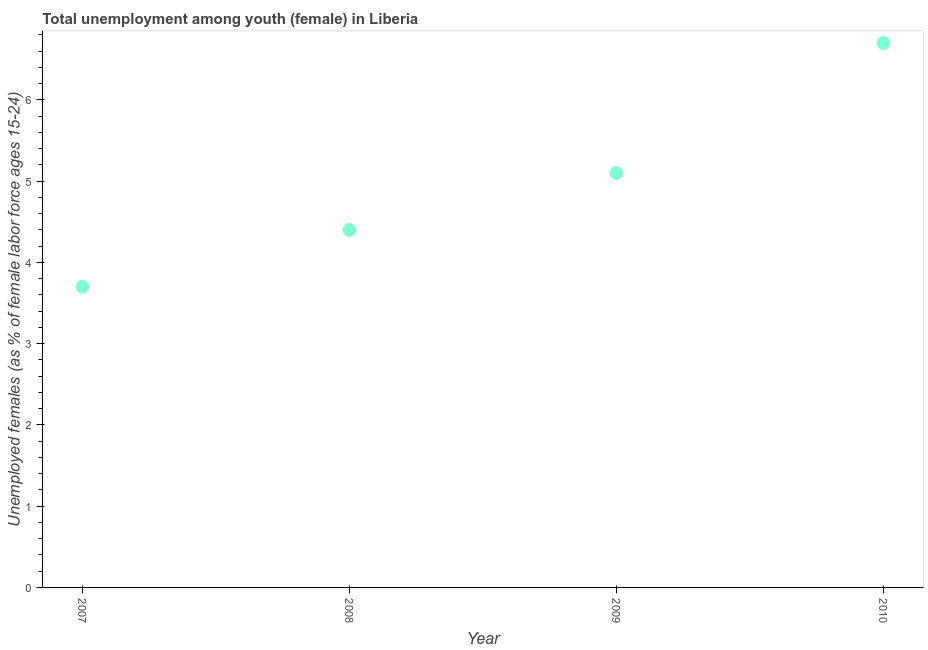What is the unemployed female youth population in 2009?
Your response must be concise. 5.1. Across all years, what is the maximum unemployed female youth population?
Offer a terse response. 6.7. Across all years, what is the minimum unemployed female youth population?
Give a very brief answer. 3.7. In which year was the unemployed female youth population maximum?
Offer a terse response. 2010. In which year was the unemployed female youth population minimum?
Your answer should be compact. 2007. What is the sum of the unemployed female youth population?
Provide a succinct answer. 19.9. What is the difference between the unemployed female youth population in 2007 and 2008?
Your answer should be very brief. -0.7. What is the average unemployed female youth population per year?
Ensure brevity in your answer.  4.97. What is the median unemployed female youth population?
Your answer should be very brief. 4.75. In how many years, is the unemployed female youth population greater than 0.4 %?
Your answer should be compact. 4. What is the ratio of the unemployed female youth population in 2008 to that in 2009?
Your answer should be very brief. 0.86. Is the unemployed female youth population in 2009 less than that in 2010?
Offer a very short reply. Yes. Is the difference between the unemployed female youth population in 2007 and 2009 greater than the difference between any two years?
Ensure brevity in your answer.  No. What is the difference between the highest and the second highest unemployed female youth population?
Your answer should be very brief. 1.6. What is the difference between the highest and the lowest unemployed female youth population?
Your answer should be very brief. 3. In how many years, is the unemployed female youth population greater than the average unemployed female youth population taken over all years?
Provide a short and direct response. 2. How many years are there in the graph?
Give a very brief answer. 4. What is the difference between two consecutive major ticks on the Y-axis?
Provide a succinct answer. 1. Does the graph contain any zero values?
Make the answer very short. No. Does the graph contain grids?
Provide a succinct answer. No. What is the title of the graph?
Your response must be concise. Total unemployment among youth (female) in Liberia. What is the label or title of the X-axis?
Offer a very short reply. Year. What is the label or title of the Y-axis?
Make the answer very short. Unemployed females (as % of female labor force ages 15-24). What is the Unemployed females (as % of female labor force ages 15-24) in 2007?
Your answer should be very brief. 3.7. What is the Unemployed females (as % of female labor force ages 15-24) in 2008?
Your answer should be compact. 4.4. What is the Unemployed females (as % of female labor force ages 15-24) in 2009?
Provide a succinct answer. 5.1. What is the Unemployed females (as % of female labor force ages 15-24) in 2010?
Give a very brief answer. 6.7. What is the difference between the Unemployed females (as % of female labor force ages 15-24) in 2007 and 2010?
Offer a very short reply. -3. What is the difference between the Unemployed females (as % of female labor force ages 15-24) in 2008 and 2010?
Provide a succinct answer. -2.3. What is the difference between the Unemployed females (as % of female labor force ages 15-24) in 2009 and 2010?
Your response must be concise. -1.6. What is the ratio of the Unemployed females (as % of female labor force ages 15-24) in 2007 to that in 2008?
Provide a succinct answer. 0.84. What is the ratio of the Unemployed females (as % of female labor force ages 15-24) in 2007 to that in 2009?
Your answer should be very brief. 0.72. What is the ratio of the Unemployed females (as % of female labor force ages 15-24) in 2007 to that in 2010?
Your answer should be compact. 0.55. What is the ratio of the Unemployed females (as % of female labor force ages 15-24) in 2008 to that in 2009?
Keep it short and to the point. 0.86. What is the ratio of the Unemployed females (as % of female labor force ages 15-24) in 2008 to that in 2010?
Offer a very short reply. 0.66. What is the ratio of the Unemployed females (as % of female labor force ages 15-24) in 2009 to that in 2010?
Make the answer very short. 0.76. 